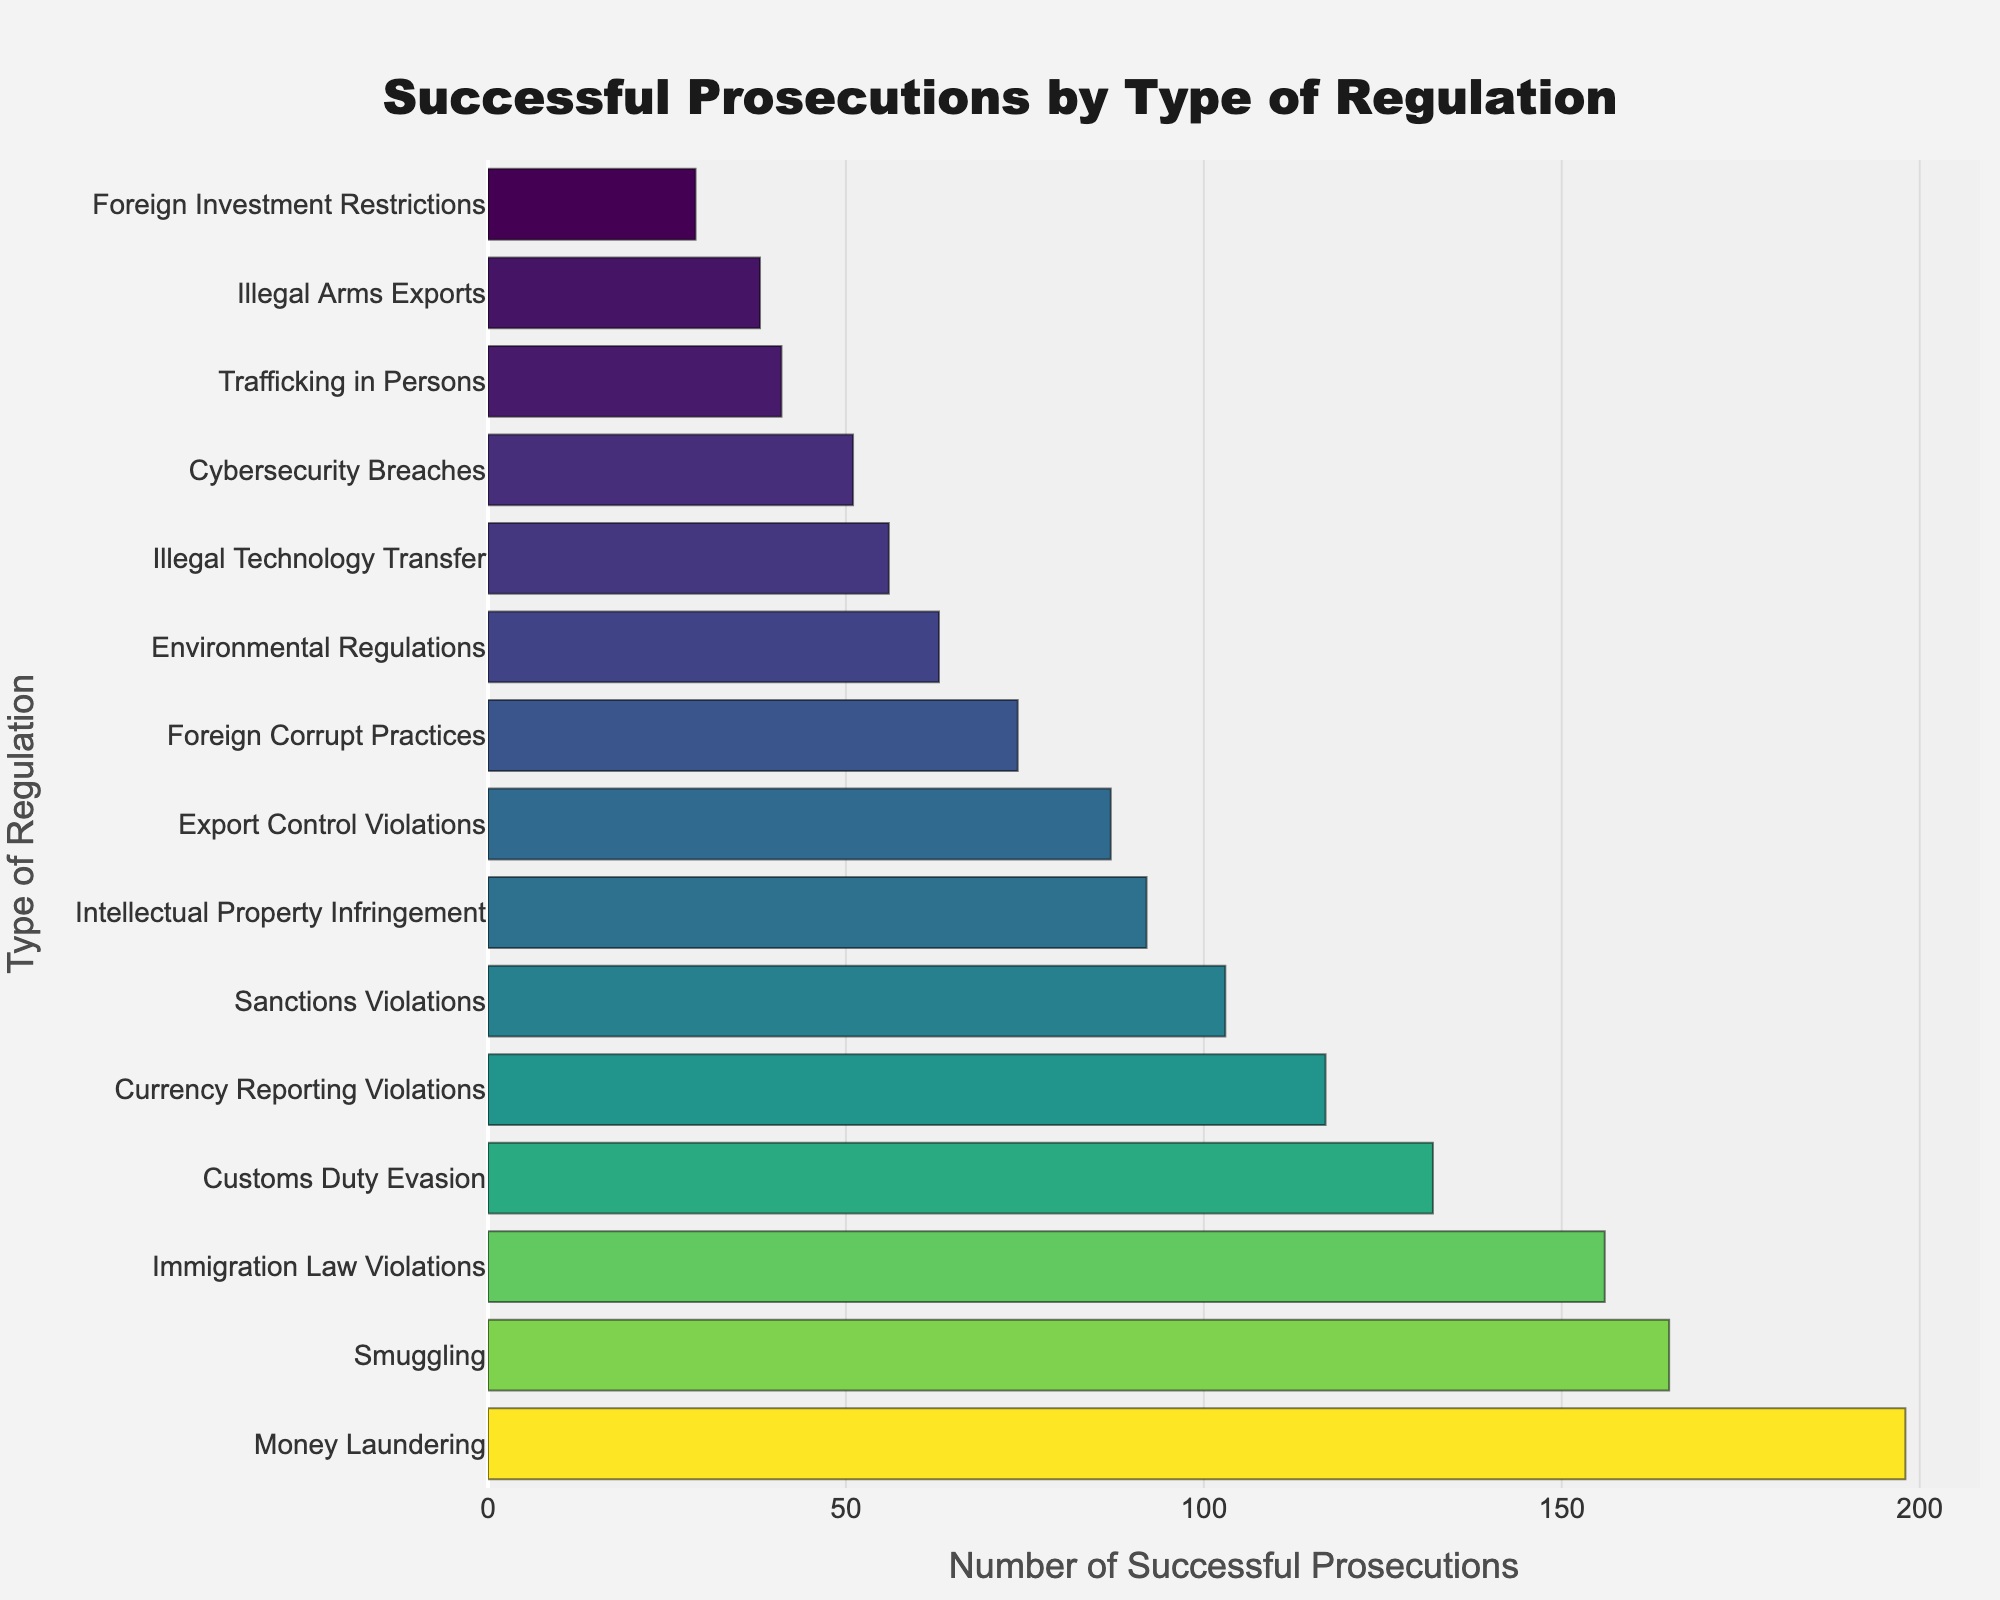How many more successful prosecutions were there for Money Laundering compared to Illegal Technology Transfer? First, identify the number of successful prosecutions for Money Laundering (198) and Illegal Technology Transfer (56). Then, subtract the smaller number from the larger number: 198 - 56 = 142.
Answer: 142 Which type of regulation had the second highest number of successful prosecutions? Look at the bars in descending order of successful prosecutions. The highest is Money Laundering (198), followed by Customs Duty Evasion (132). Therefore, the second highest is Customs Duty Evasion.
Answer: Customs Duty Evasion What is the total number of successful prosecutions for Environmental Regulations and Immigration Law Violations combined? Add the number of successful prosecutions for both types of regulations. Environmental Regulations have 63 prosecutions, and Immigration Law Violations have 156. Therefore, the total is 63 + 156 = 219.
Answer: 219 Are there more successful prosecutions for Sanctions Violations or Cybersecurity Breaches? Compare the number of successful prosecutions for Sanctions Violations (103) against Cybersecurity Breaches (51). 103 is greater than 51.
Answer: Sanctions Violations What is the average number of successful prosecutions for Export Control Violations, Smuggling, and Illegal Arms Exports? First sum the successful prosecutions for the three types: 87 (Export Control Violations) + 165 (Smuggling) + 38 (Illegal Arms Exports) = 290. Then divide by the number of categories: 290 / 3 ≈ 96.67.
Answer: Approximately 96.67 Which type of regulation has the lowest number of successful prosecutions? Identify the bar with the smallest length, which corresponds to Foreign Investment Restrictions with 29 successful prosecutions.
Answer: Foreign Investment Restrictions How many types of regulations have more than 100 successful prosecutions? Identify the types with prosecution numbers greater than 100. They are Money Laundering (198), Customs Duty Evasion (132), Sanctions Violations (103), Smuggling (165), and Immigration Law Violations (156). That makes 5 categories.
Answer: 5 Is the number of successful prosecutions for Customs Duty Evasion closer to those for Intellectual Property Infringement or Currency Reporting Violations? Customs Duty Evasion has 132 prosecutions, Intellectual Property Infringement has 92, and Currency Reporting Violations has 117. Calculate the differences: 132 - 92 = 40 and 132 - 117 = 15. Since 15 is smaller than 40, Customs Duty Evasion is closer to Currency Reporting Violations.
Answer: Currency Reporting Violations What is the difference in the number of successful prosecutions between the third and fourth highest categories? Identify the third highest (Sanctions Violations with 103) and the fourth highest (Currency Reporting Violations with 117) categories. Then, subtract: 117 - 103 = 14.
Answer: 14 Which regulation type has slightly more successful prosecutions, Illegal Arms Exports or Trafficking in Persons? Compare the number of successful prosecutions: Illegal Arms Exports (38) and Trafficking in Persons (41). 41 is slightly more than 38.
Answer: Trafficking in Persons 